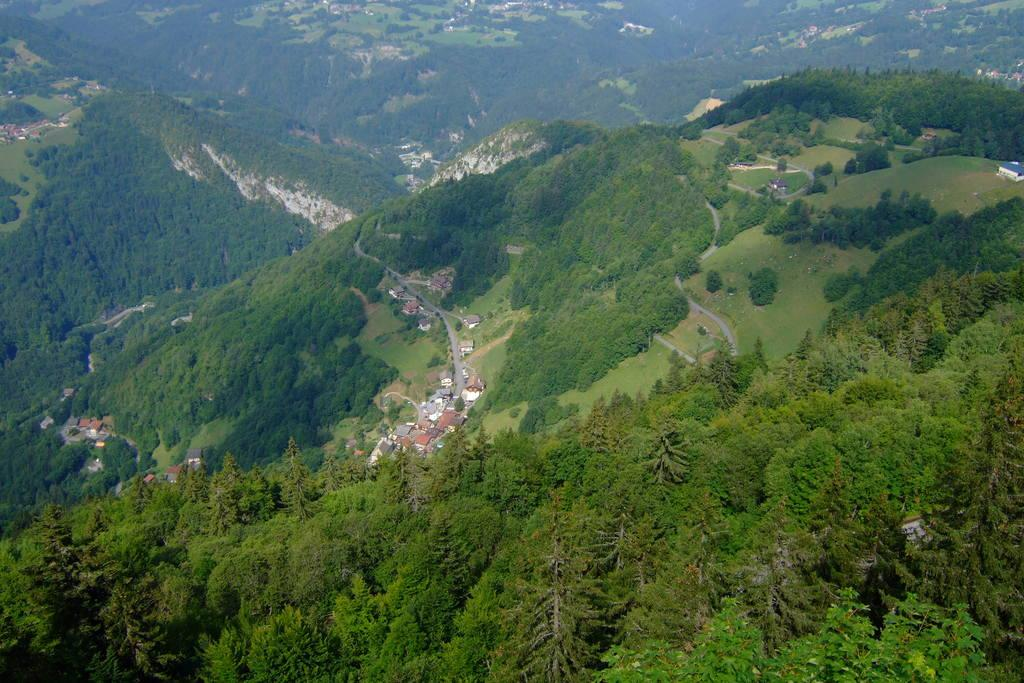What type of landscape is depicted in the image? The image features hills. What can be seen at the bottom of the hills? Trees and sheds are visible at the bottom of the image. What type of love story is being told in the image? There is no love story present in the image; it features hills, trees, and sheds. 